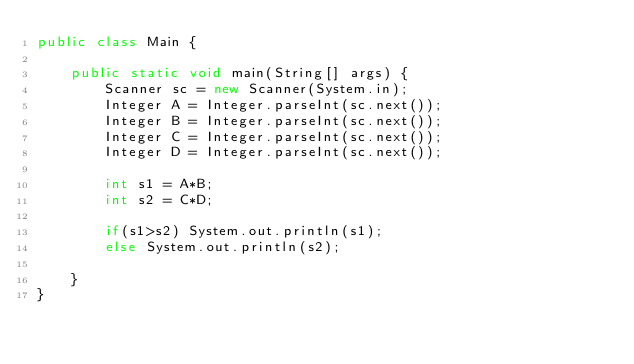<code> <loc_0><loc_0><loc_500><loc_500><_Java_>public class Main {

    public static void main(String[] args) {
        Scanner sc = new Scanner(System.in);
        Integer A = Integer.parseInt(sc.next());
        Integer B = Integer.parseInt(sc.next());
        Integer C = Integer.parseInt(sc.next());
        Integer D = Integer.parseInt(sc.next());

        int s1 = A*B;
        int s2 = C*D;

        if(s1>s2) System.out.println(s1);
        else System.out.println(s2);

    }
}
</code> 